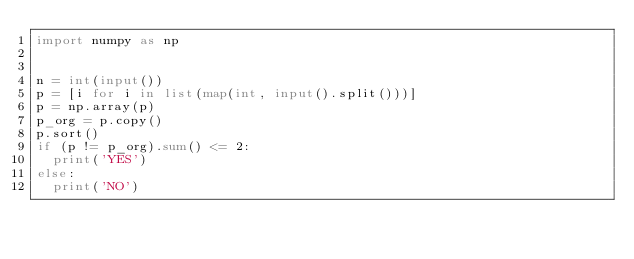<code> <loc_0><loc_0><loc_500><loc_500><_Python_>import numpy as np


n = int(input())
p = [i for i in list(map(int, input().split()))]
p = np.array(p)
p_org = p.copy()
p.sort()
if (p != p_org).sum() <= 2:
  print('YES')
else:
  print('NO')</code> 